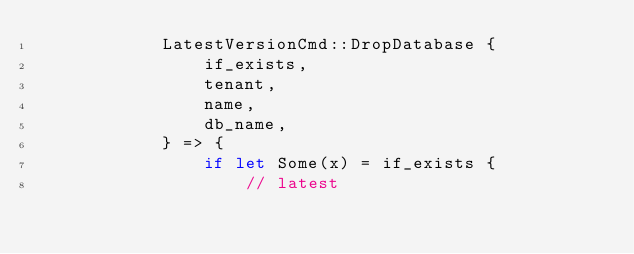<code> <loc_0><loc_0><loc_500><loc_500><_Rust_>            LatestVersionCmd::DropDatabase {
                if_exists,
                tenant,
                name,
                db_name,
            } => {
                if let Some(x) = if_exists {
                    // latest</code> 